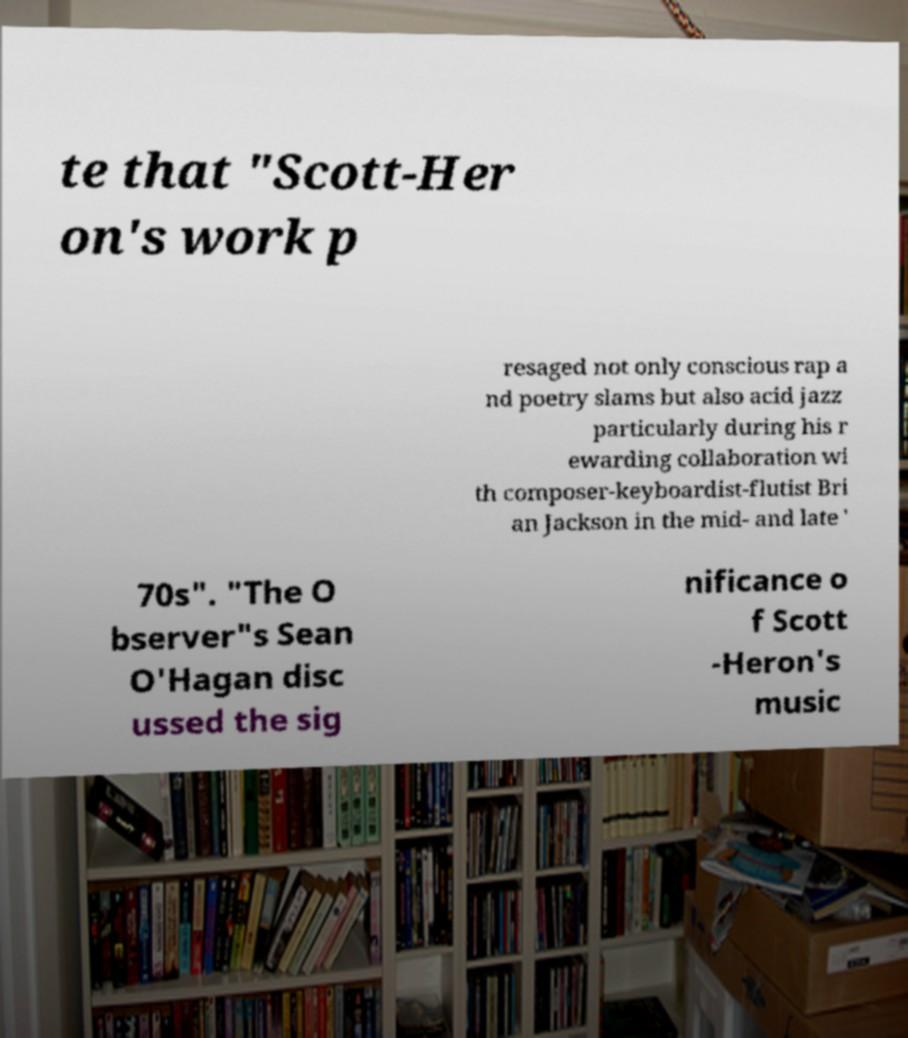Please identify and transcribe the text found in this image. te that "Scott-Her on's work p resaged not only conscious rap a nd poetry slams but also acid jazz particularly during his r ewarding collaboration wi th composer-keyboardist-flutist Bri an Jackson in the mid- and late ' 70s". "The O bserver"s Sean O'Hagan disc ussed the sig nificance o f Scott -Heron's music 